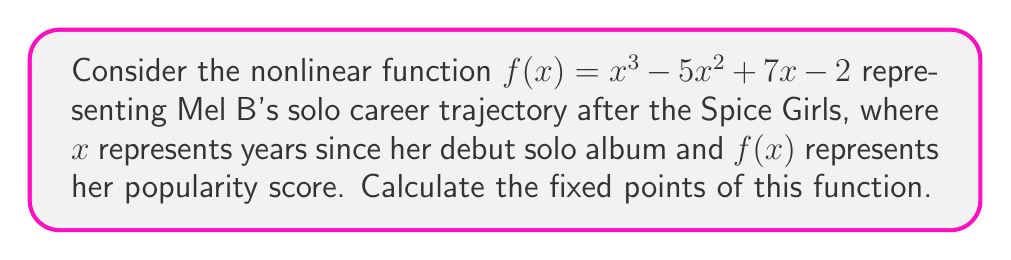Can you answer this question? To find the fixed points of the function $f(x) = x^3 - 5x^2 + 7x - 2$, we need to solve the equation $f(x) = x$:

1) Set up the equation:
   $x^3 - 5x^2 + 7x - 2 = x$

2) Rearrange to standard form:
   $x^3 - 5x^2 + 6x - 2 = 0$

3) This is a cubic equation. We can solve it using the rational root theorem. The possible rational roots are the factors of the constant term: $\pm 1, \pm 2$

4) Testing these values:
   $f(1) = 1^3 - 5(1)^2 + 6(1) - 2 = 1 - 5 + 6 - 2 = 0$
   $f(2) = 2^3 - 5(2)^2 + 6(2) - 2 = 8 - 20 + 12 - 2 = -2 \neq 0$
   $f(-1) = (-1)^3 - 5(-1)^2 + 6(-1) - 2 = -1 - 5 - 6 - 2 = -14 \neq 0$
   $f(-2) = (-2)^3 - 5(-2)^2 + 6(-2) - 2 = -8 - 20 - 12 - 2 = -42 \neq 0$

5) We found that $x = 1$ is a root. We can factor out $(x-1)$:
   $x^3 - 5x^2 + 6x - 2 = (x-1)(x^2 - 4x + 2)$

6) Solve the quadratic equation $x^2 - 4x + 2 = 0$ using the quadratic formula:
   $x = \frac{4 \pm \sqrt{16 - 8}}{2} = \frac{4 \pm \sqrt{8}}{2} = \frac{4 \pm 2\sqrt{2}}{2} = 2 \pm \sqrt{2}$

Therefore, the fixed points are $x = 1$, $x = 2 + \sqrt{2}$, and $x = 2 - \sqrt{2}$.
Answer: $x = 1$, $x = 2 + \sqrt{2}$, $x = 2 - \sqrt{2}$ 